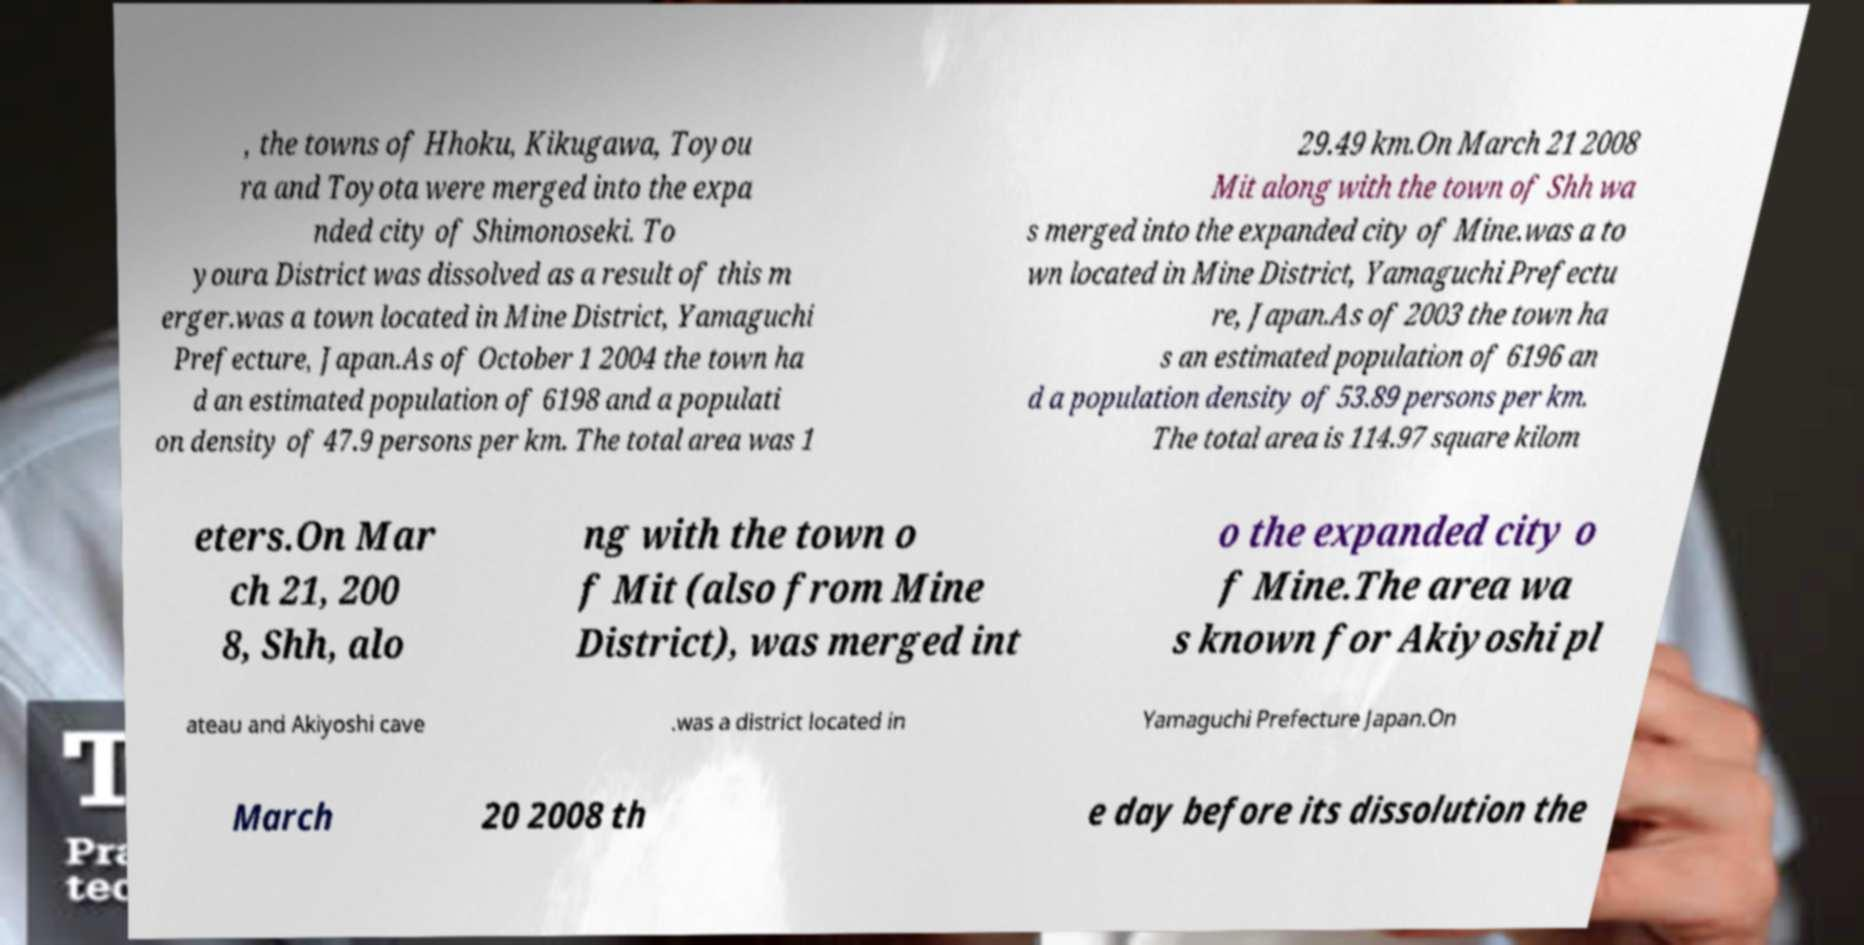Could you extract and type out the text from this image? , the towns of Hhoku, Kikugawa, Toyou ra and Toyota were merged into the expa nded city of Shimonoseki. To youra District was dissolved as a result of this m erger.was a town located in Mine District, Yamaguchi Prefecture, Japan.As of October 1 2004 the town ha d an estimated population of 6198 and a populati on density of 47.9 persons per km. The total area was 1 29.49 km.On March 21 2008 Mit along with the town of Shh wa s merged into the expanded city of Mine.was a to wn located in Mine District, Yamaguchi Prefectu re, Japan.As of 2003 the town ha s an estimated population of 6196 an d a population density of 53.89 persons per km. The total area is 114.97 square kilom eters.On Mar ch 21, 200 8, Shh, alo ng with the town o f Mit (also from Mine District), was merged int o the expanded city o f Mine.The area wa s known for Akiyoshi pl ateau and Akiyoshi cave .was a district located in Yamaguchi Prefecture Japan.On March 20 2008 th e day before its dissolution the 